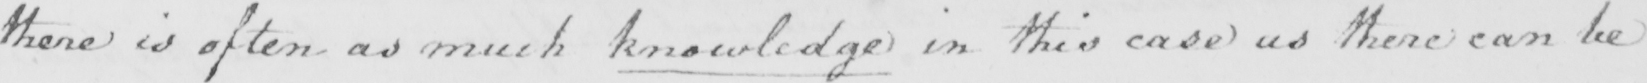What text is written in this handwritten line? there is often as much knowledge in this case as there can be 